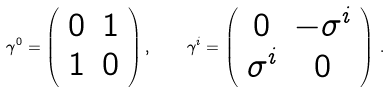Convert formula to latex. <formula><loc_0><loc_0><loc_500><loc_500>\gamma ^ { 0 } = \left ( \begin{array} { c c } 0 & 1 \\ 1 & 0 \end{array} \right ) , \quad \gamma ^ { i } = \left ( \begin{array} { c c } 0 & - \sigma ^ { i } \\ \sigma ^ { i } & 0 \end{array} \right ) \, .</formula> 